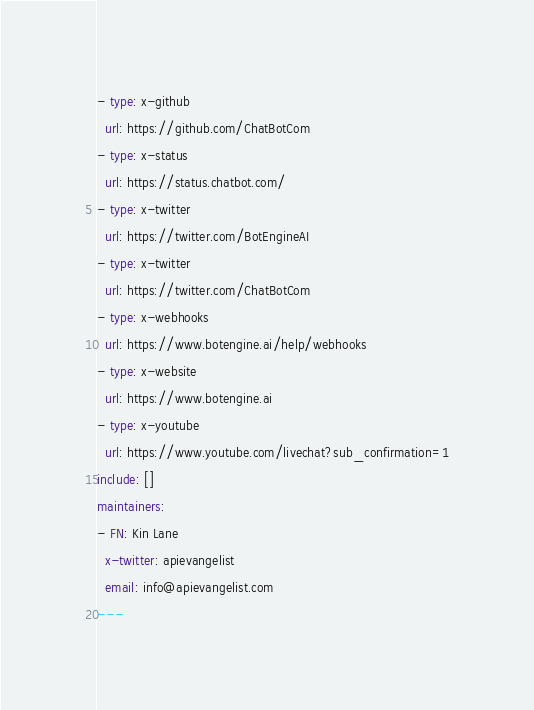<code> <loc_0><loc_0><loc_500><loc_500><_YAML_>- type: x-github
  url: https://github.com/ChatBotCom
- type: x-status
  url: https://status.chatbot.com/
- type: x-twitter
  url: https://twitter.com/BotEngineAI
- type: x-twitter
  url: https://twitter.com/ChatBotCom
- type: x-webhooks
  url: https://www.botengine.ai/help/webhooks
- type: x-website
  url: https://www.botengine.ai
- type: x-youtube
  url: https://www.youtube.com/livechat?sub_confirmation=1
include: []
maintainers:
- FN: Kin Lane
  x-twitter: apievangelist
  email: info@apievangelist.com
---</code> 